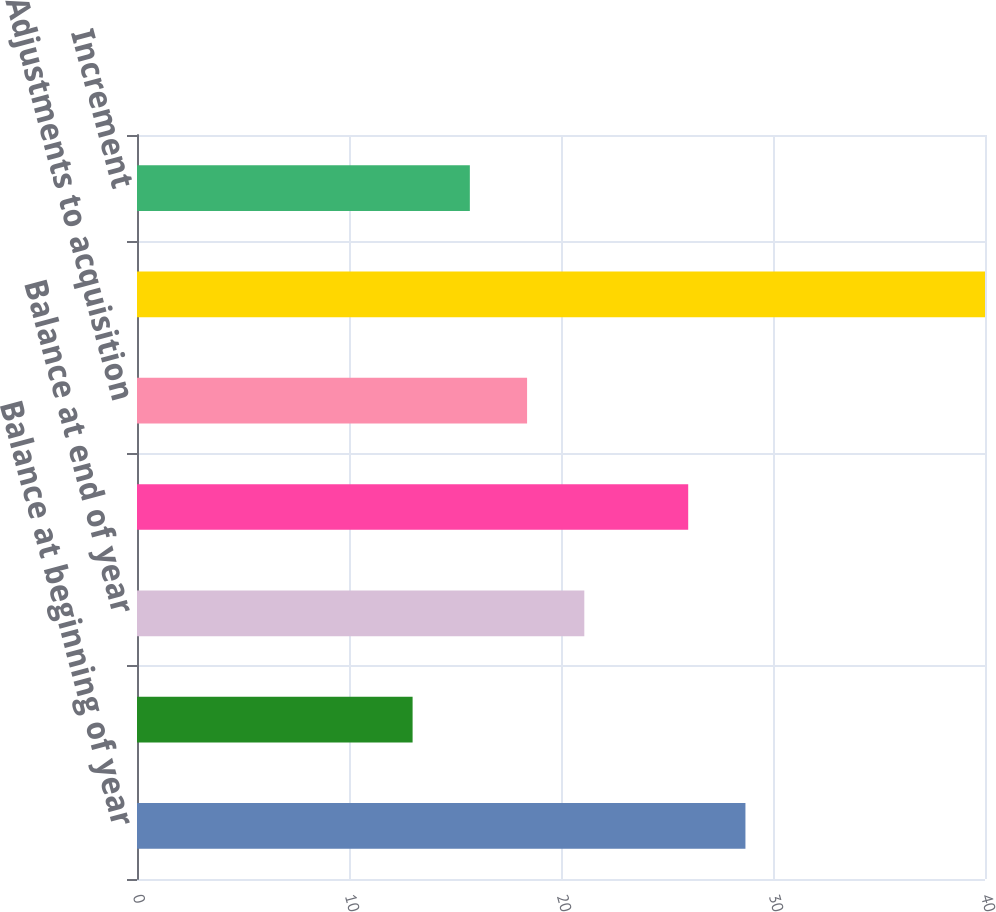Convert chart to OTSL. <chart><loc_0><loc_0><loc_500><loc_500><bar_chart><fcel>Balance at beginning of year<fcel>Bad debt write-offs<fcel>Balance at end of year<fcel>Additions charged to expense<fcel>Adjustments to acquisition<fcel>Net amounts utilized for<fcel>Increment<nl><fcel>28.7<fcel>13<fcel>21.1<fcel>26<fcel>18.4<fcel>40<fcel>15.7<nl></chart> 